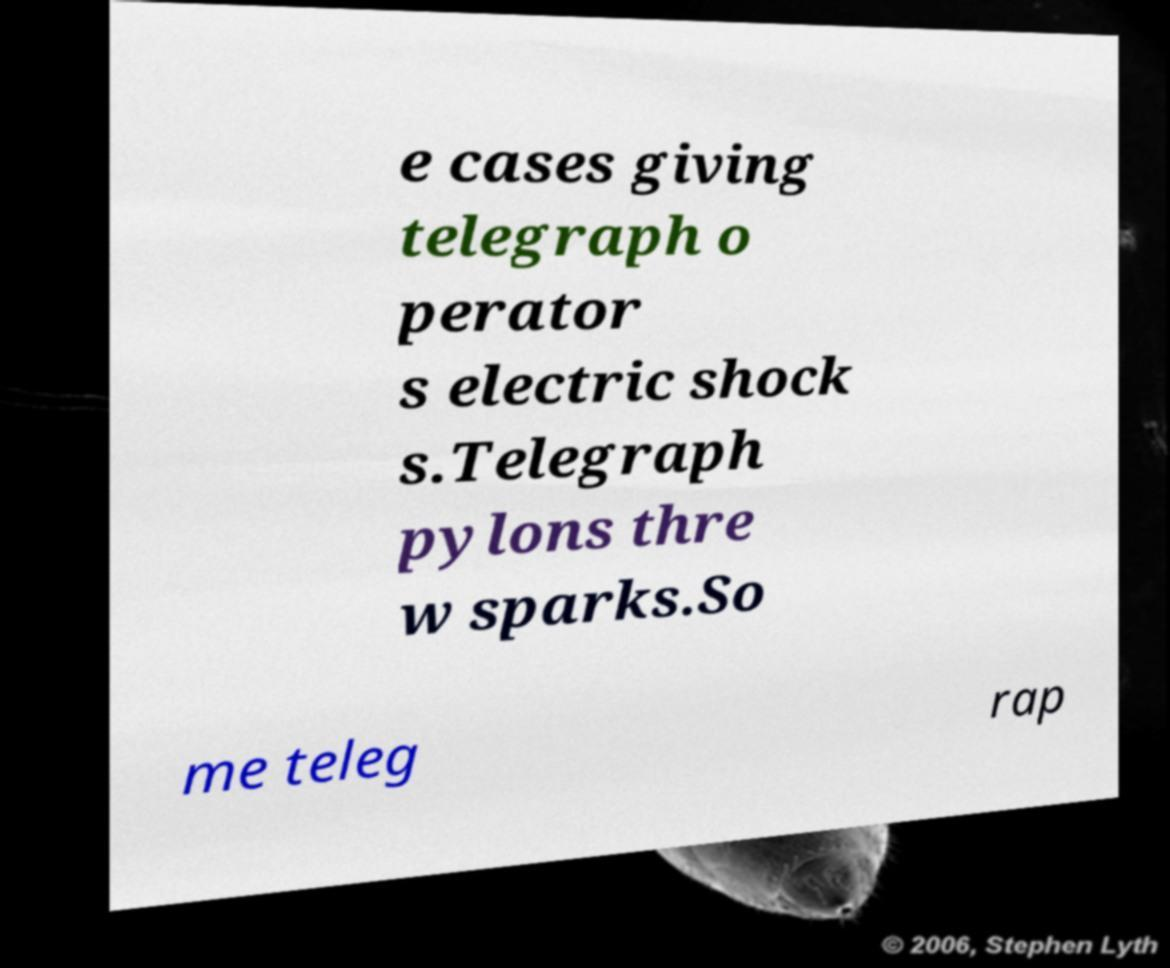Could you extract and type out the text from this image? e cases giving telegraph o perator s electric shock s.Telegraph pylons thre w sparks.So me teleg rap 